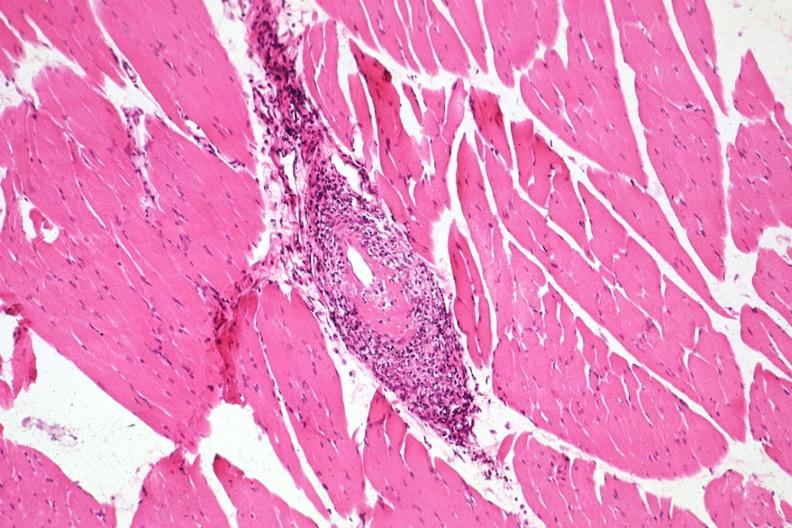s muscle present?
Answer the question using a single word or phrase. Yes 